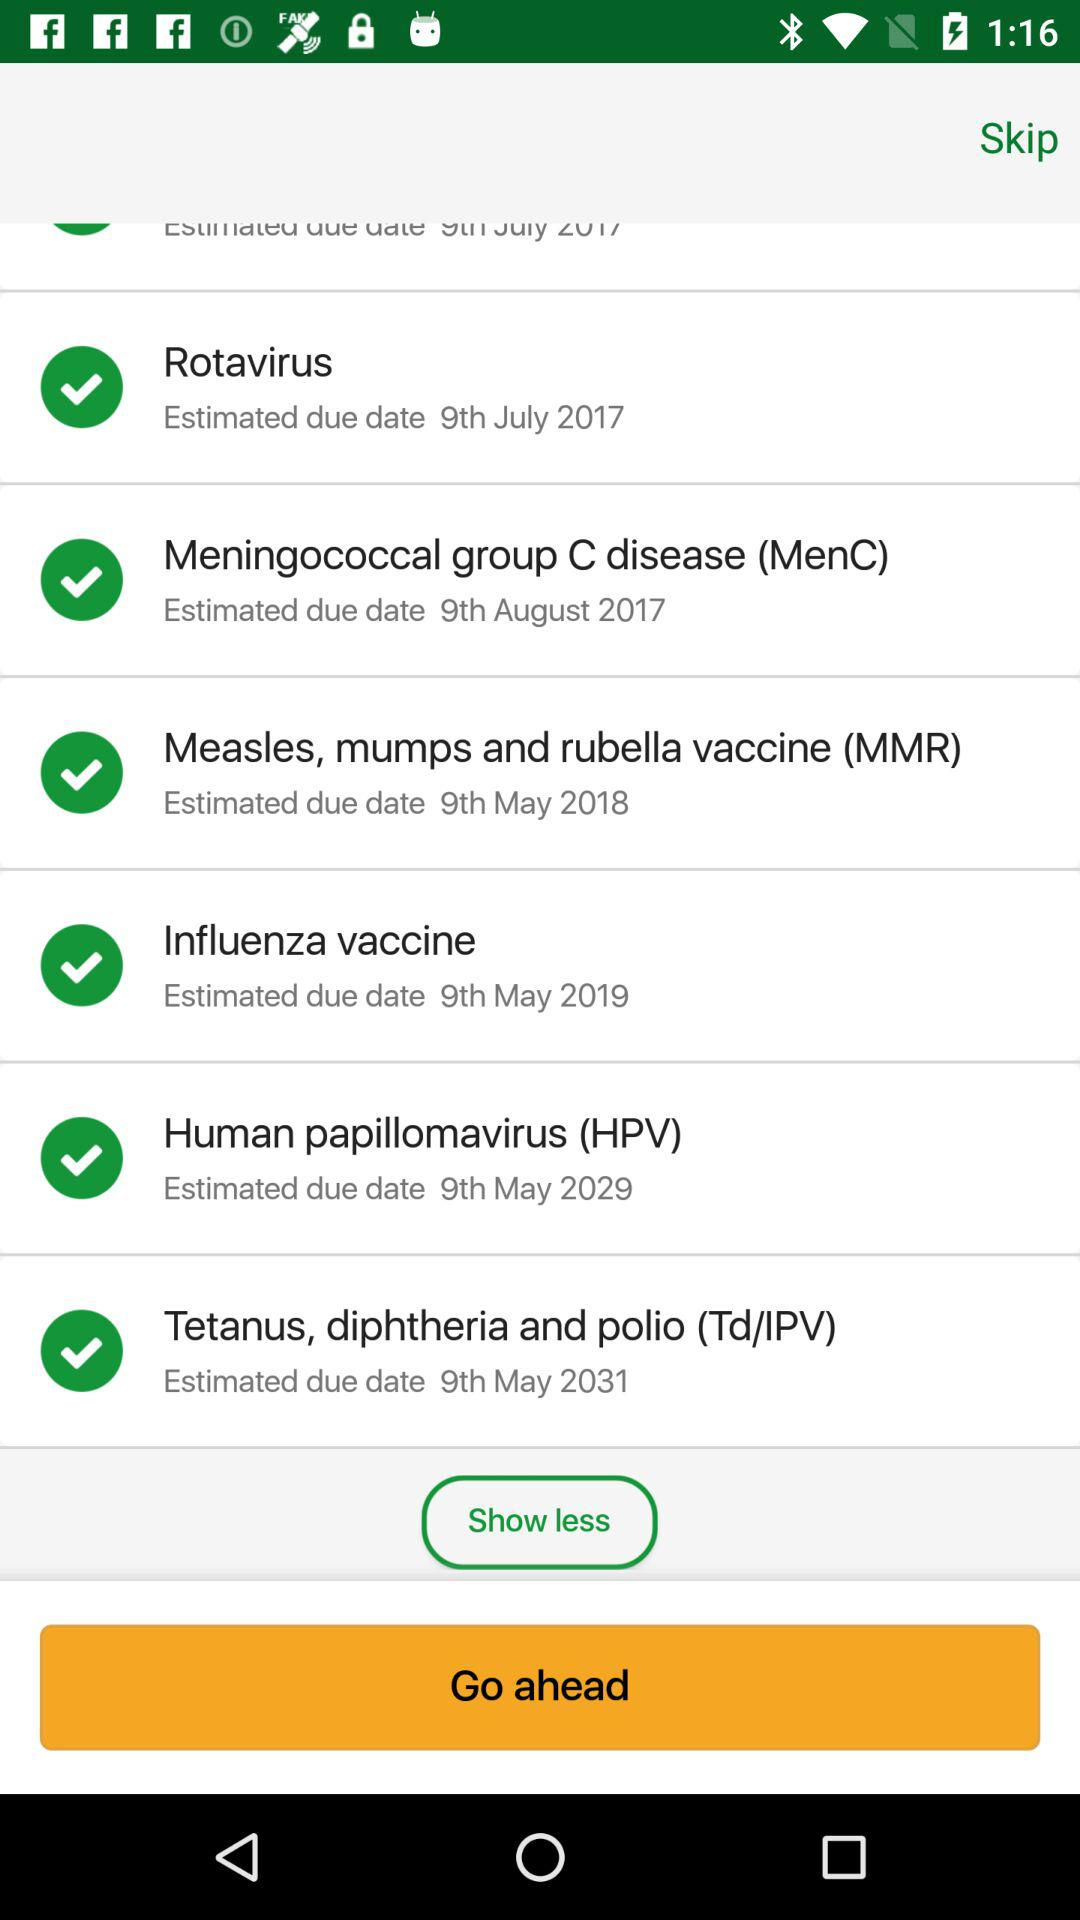What is the full form of HPV? The full form of HPV is "Human papillomavirus". 